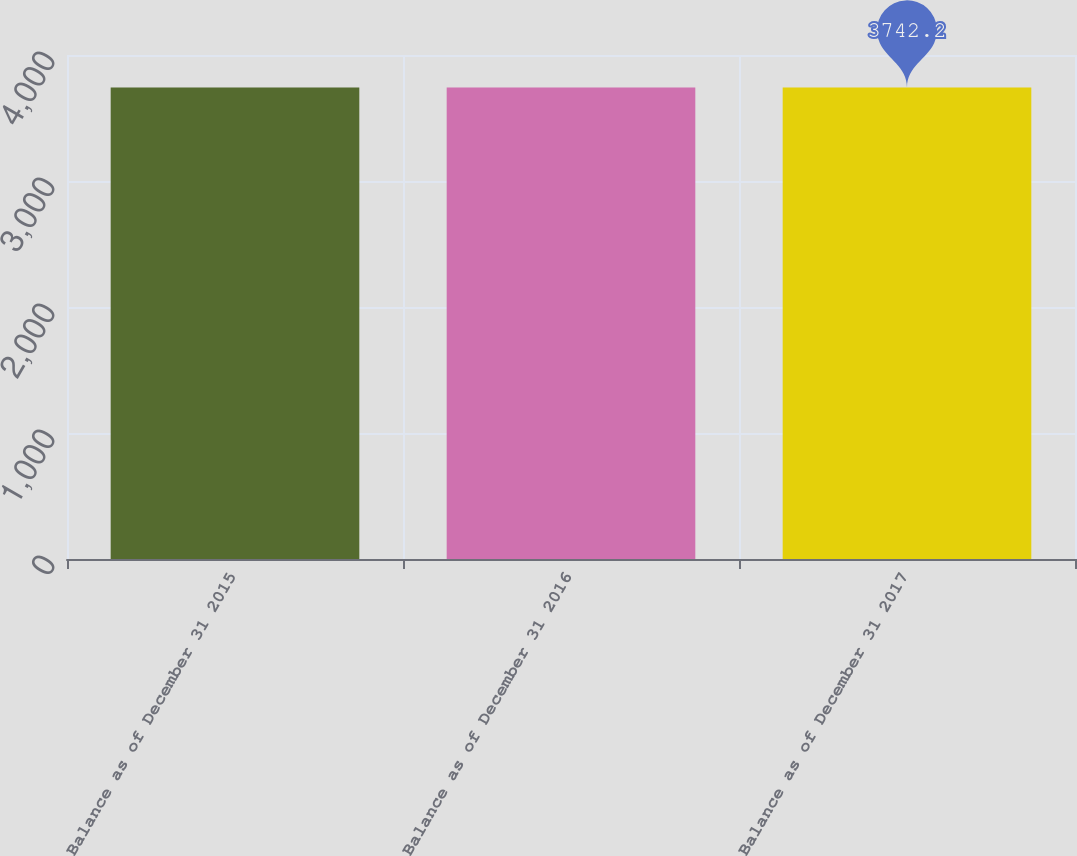<chart> <loc_0><loc_0><loc_500><loc_500><bar_chart><fcel>Balance as of December 31 2015<fcel>Balance as of December 31 2016<fcel>Balance as of December 31 2017<nl><fcel>3742<fcel>3742.1<fcel>3742.2<nl></chart> 